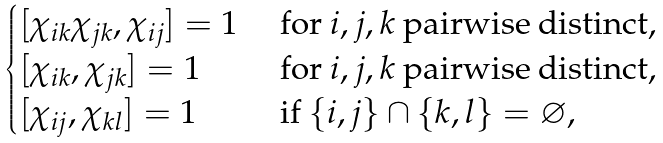<formula> <loc_0><loc_0><loc_500><loc_500>\begin{cases} [ \chi _ { i k } \chi _ { j k } , \chi _ { i j } ] = 1 & \text { for $i,j,k$ pairwise distinct,} \\ [ \chi _ { i k } , \chi _ { j k } ] = 1 & \text { for $i,j,k$ pairwise distinct,} \\ [ \chi _ { i j } , \chi _ { k l } ] = 1 & \text { if } \{ i , j \} \cap \{ k , l \} = \varnothing , \end{cases}</formula> 